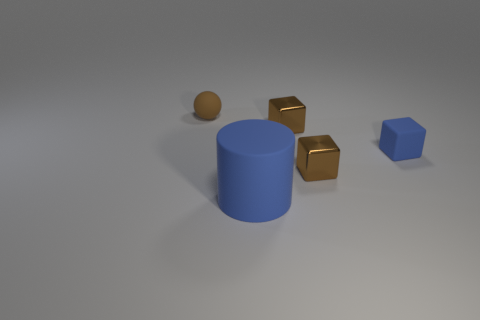Subtract all tiny shiny cubes. How many cubes are left? 1 Subtract all green cylinders. How many brown blocks are left? 2 Add 2 brown things. How many objects exist? 7 Subtract all blue blocks. How many blocks are left? 2 Subtract all cylinders. How many objects are left? 4 Subtract 1 blue cubes. How many objects are left? 4 Subtract 1 blocks. How many blocks are left? 2 Subtract all gray cylinders. Subtract all cyan blocks. How many cylinders are left? 1 Subtract all metallic objects. Subtract all blue blocks. How many objects are left? 2 Add 4 blue cubes. How many blue cubes are left? 5 